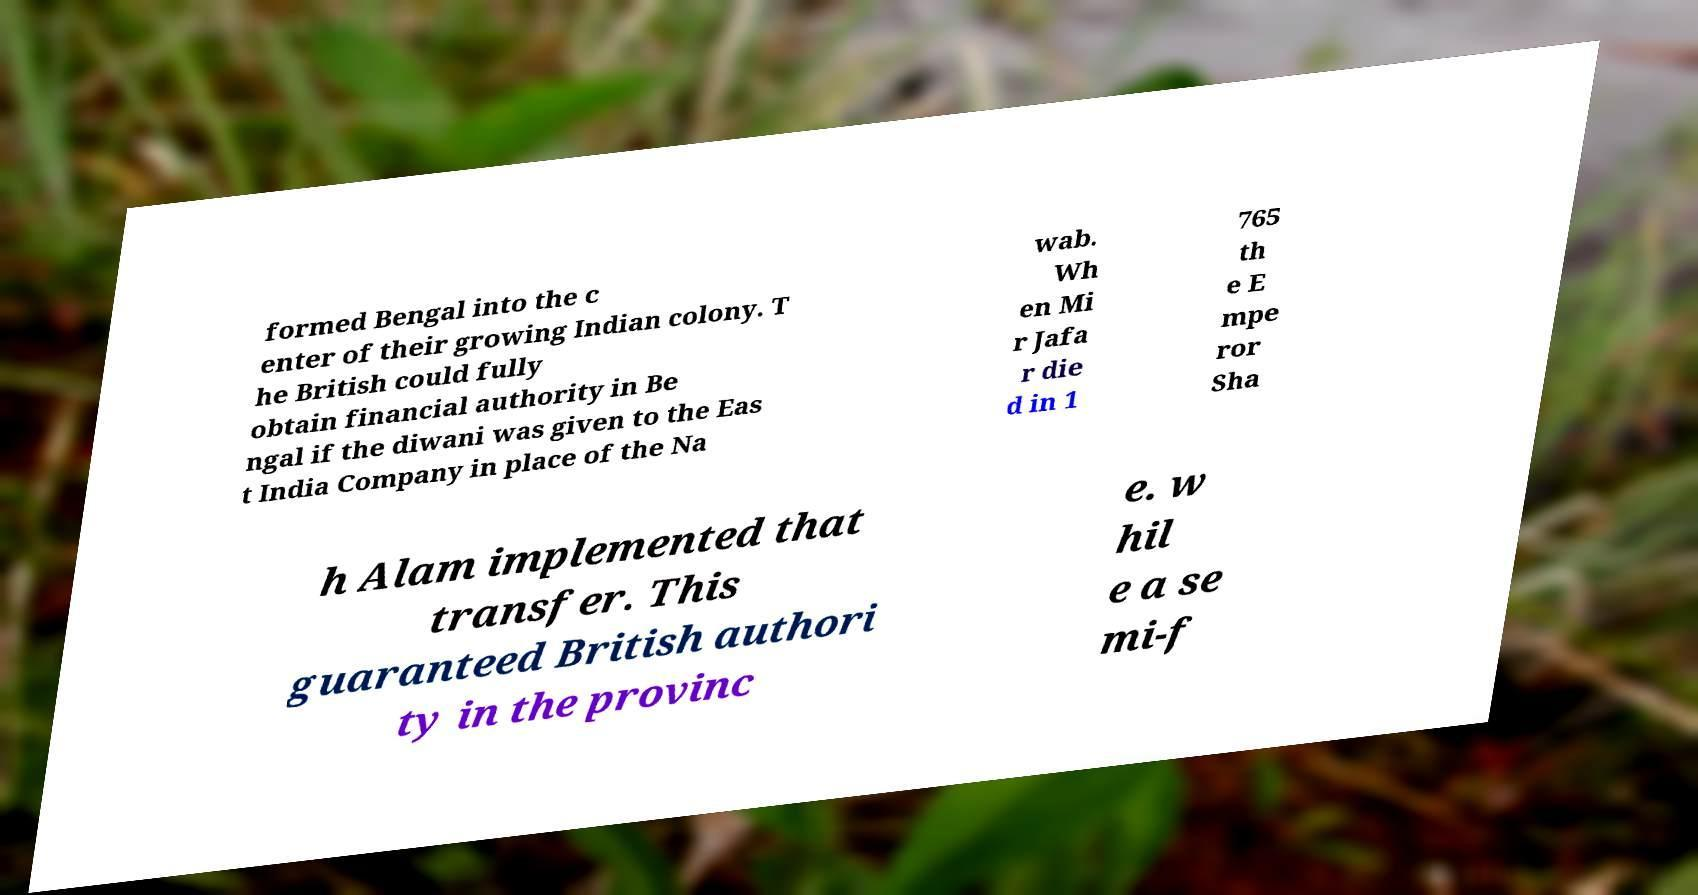Can you accurately transcribe the text from the provided image for me? formed Bengal into the c enter of their growing Indian colony. T he British could fully obtain financial authority in Be ngal if the diwani was given to the Eas t India Company in place of the Na wab. Wh en Mi r Jafa r die d in 1 765 th e E mpe ror Sha h Alam implemented that transfer. This guaranteed British authori ty in the provinc e. w hil e a se mi-f 